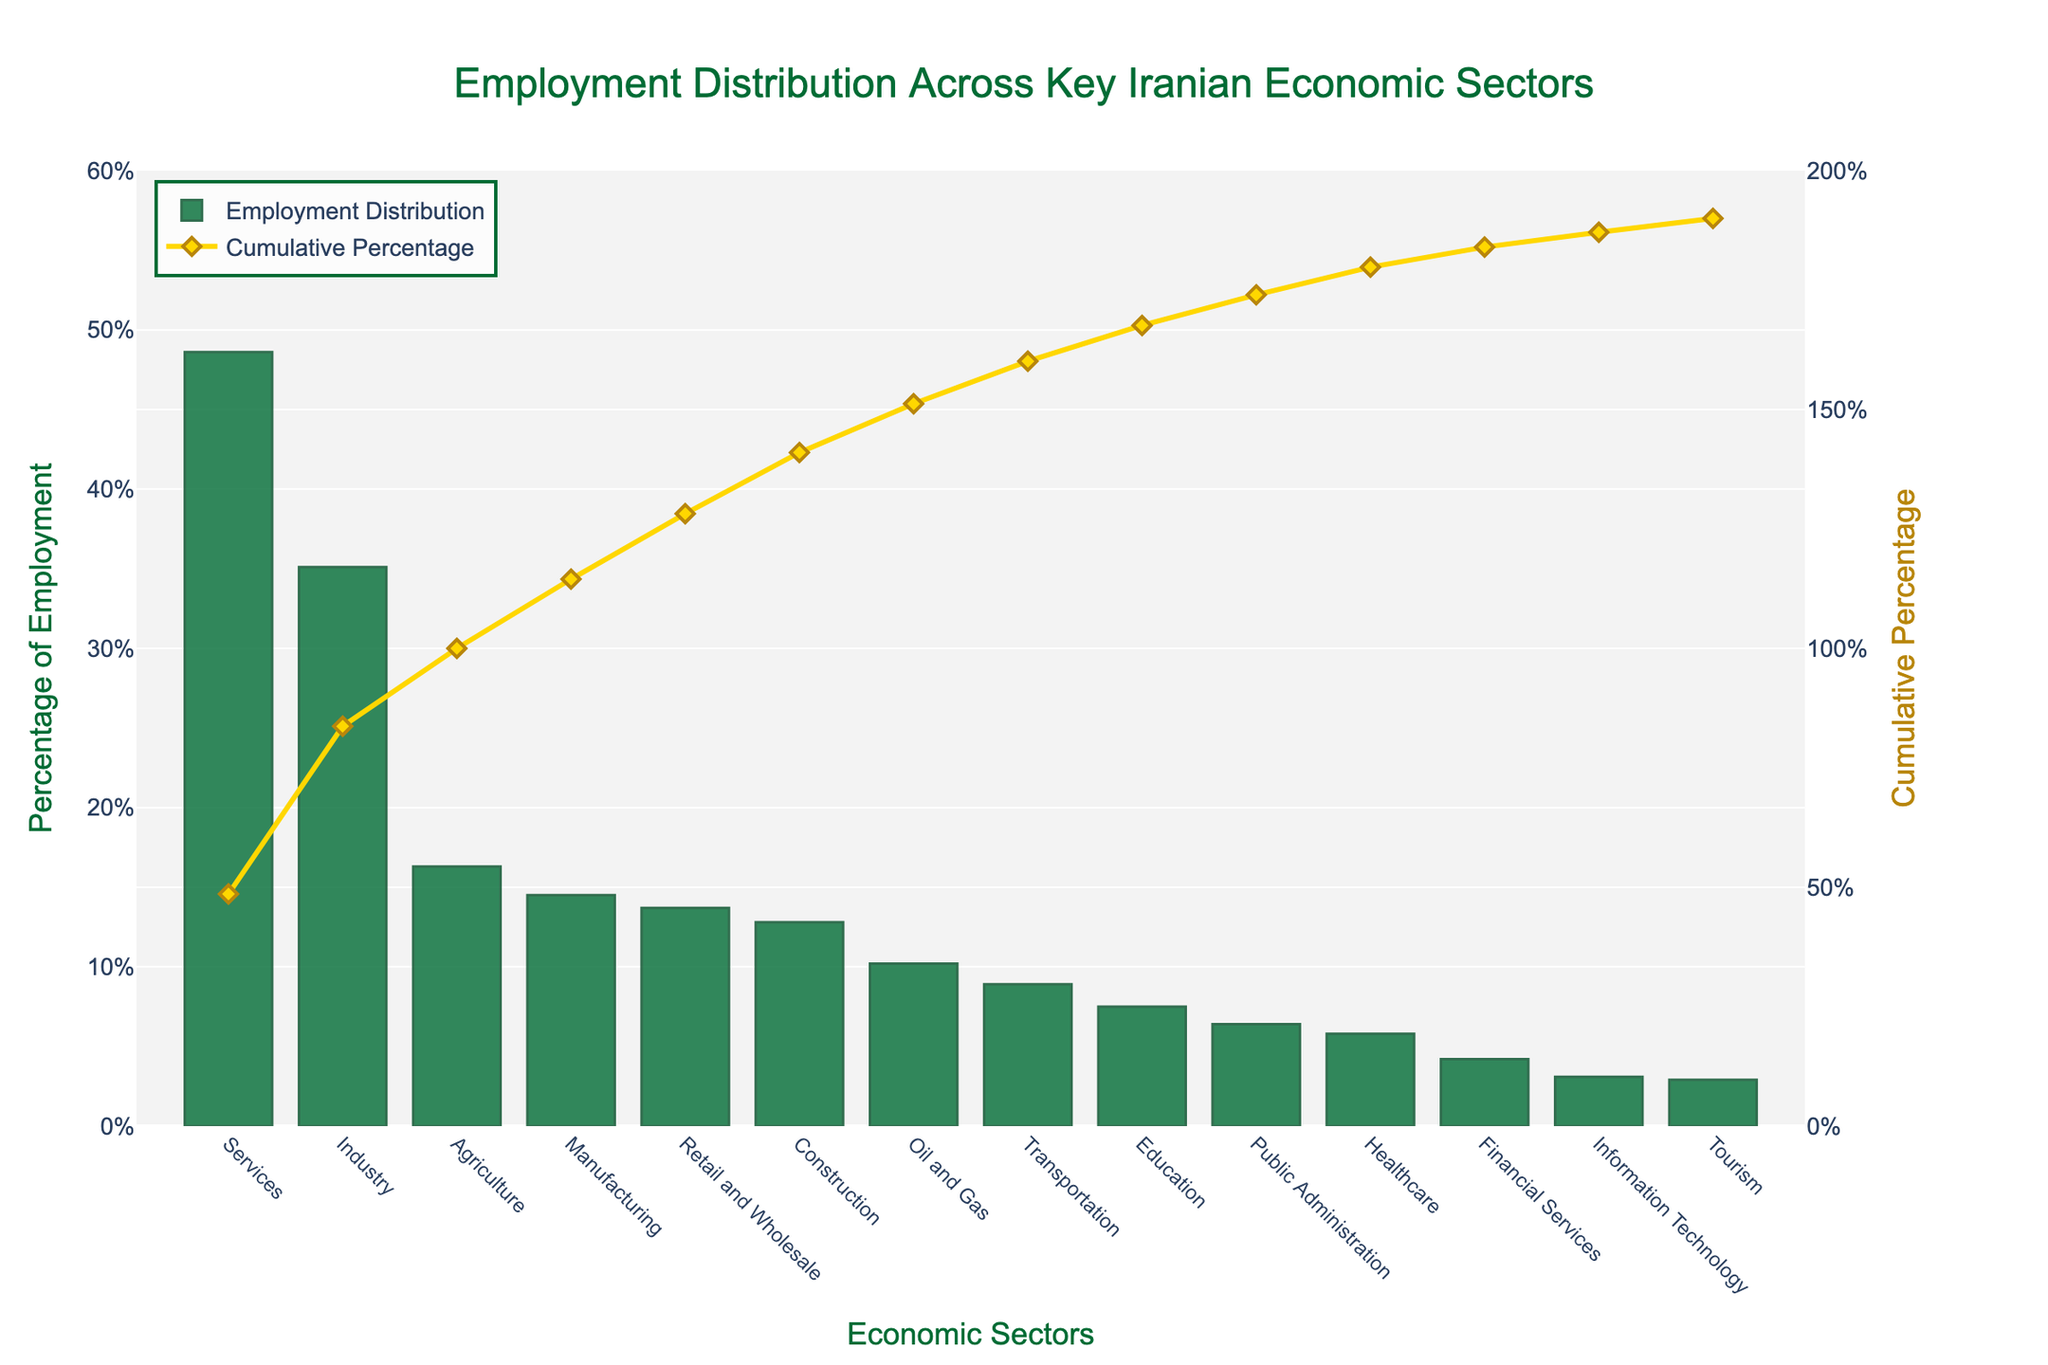What is the employment percentage for the Services sector? Refer to the height of the bar corresponding to the Services sector. The bar chart clearly shows the percentage value
Answer: 48.6% Which sector has the lowest employment percentage? Identify the shortest bar in the chart, which represents the sector with the lowest value
Answer: Tourism What is the difference in employment percentages between the Industry and Agriculture sectors? Subtract the percentage of the Agriculture sector (16.3%) from the percentage of the Industry sector (35.1%)
Answer: 18.8% How do the employment percentages in the Oil and Gas sector compare to those in the Manufacturing sector? Compare the heights of the bars for Oil and Gas (10.2%) and Manufacturing (14.5%). Manufacturing has a higher percentage
Answer: Manufacturing is higher What is the total employment percentage for the Construction and Retail and Wholesale sectors combined? Add the percentages for Construction (12.8%) and Retail and Wholesale (13.7%)
Answer: 26.5% Which sector has the higher cumulative percentage: Transportation or Education? Look at the second y-axis representing cumulative percentage and identify the points for Transportation and Education. Compare their values
Answer: Education What is the median value of the employment percentages across all sectors? Sort the percentages in ascending order, then find the middle value. Since there are 14 sectors, the median is the average of the 7th and 8th values (10.2% and 12.8%)
Answer: 11.5% Is the cumulative percentage reaching 100% before or after the Healthcare sector? Look at where the cumulative percentage line passes 100% relative to the Healthcare sector's bar
Answer: After How do the visual representations of the Agriculture and Financial Services sectors differ in terms of height and color? The Agriculture sector bar is taller and darker (green) compared to the Financial Services sector which is shorter and has the same green but lighter due to its size
Answer: Agriculture is taller, both are green Which sector's bar reaches the closest to 50% employment percentage? Identify the bar that is closest to the 50% mark on the y-axis
Answer: Services 